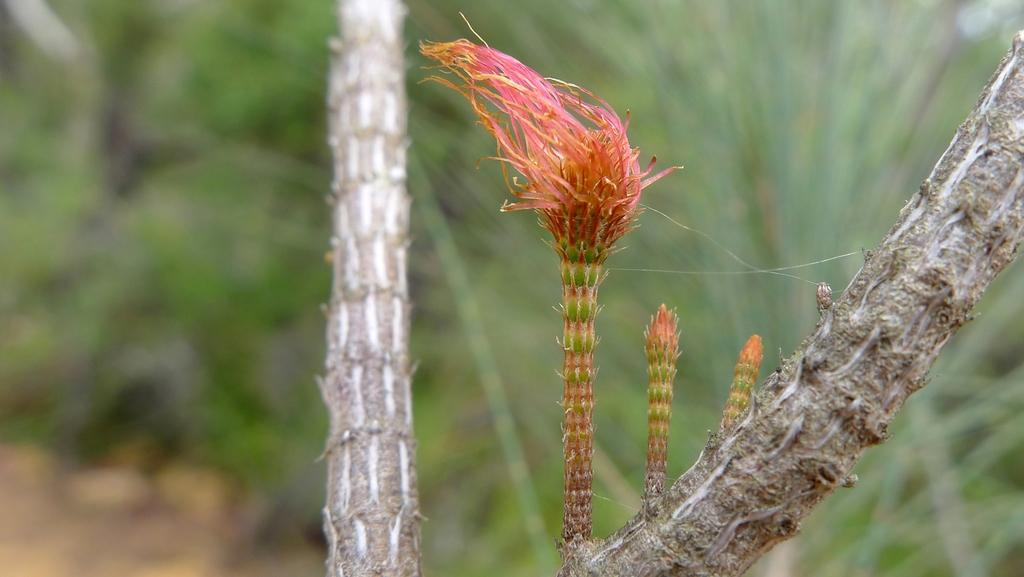What type of plant is visible in the image? There is a wild flower in the image. What else can be seen in the image besides the wild flower? There is a branch in the image. What can be seen in the background of the image? There is greenery in the background of the image. What type of rice can be seen growing in the image? There is no rice present in the image; it features a wild flower and a branch. 